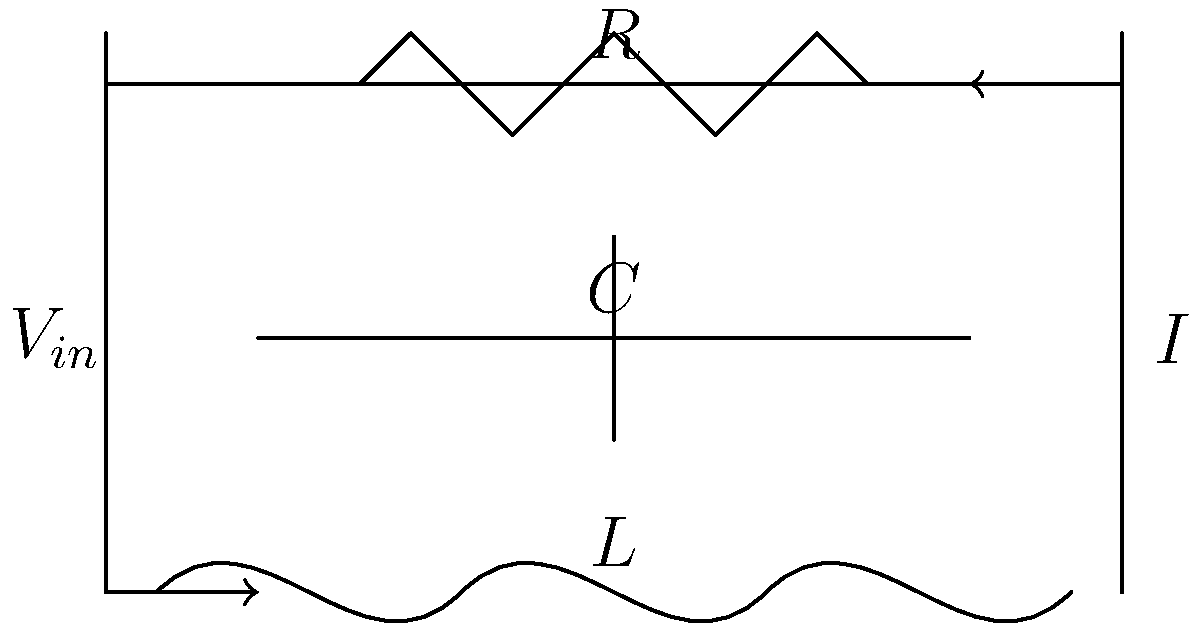In the given circuit diagram representing the electrical activity of gut smooth muscle cells, what is the impedance $Z$ of the circuit at angular frequency $\omega$? To find the impedance of the circuit, we need to follow these steps:

1) Identify the components: The circuit consists of a resistor (R), capacitor (C), and inductor (L) connected in parallel.

2) Recall the impedance formulas for each component:
   - Resistor: $Z_R = R$
   - Capacitor: $Z_C = \frac{1}{j\omega C}$
   - Inductor: $Z_L = j\omega L$

3) For components in parallel, we use the reciprocal of the sum of reciprocals:

   $\frac{1}{Z} = \frac{1}{Z_R} + \frac{1}{Z_C} + \frac{1}{Z_L}$

4) Substitute the component impedances:

   $\frac{1}{Z} = \frac{1}{R} + \frac{1}{\frac{1}{j\omega C}} + \frac{1}{j\omega L}$

5) Simplify:

   $\frac{1}{Z} = \frac{1}{R} + j\omega C + \frac{1}{j\omega L}$

6) Find a common denominator:

   $\frac{1}{Z} = \frac{1}{R} + \frac{j\omega C(j\omega L) + 1}{j\omega L} = \frac{1}{R} + \frac{-\omega^2CL + 1}{j\omega L}$

7) The total impedance is the reciprocal of this sum:

   $Z = \frac{1}{\frac{1}{R} + \frac{-\omega^2CL + 1}{j\omega L}}$

This formula represents the total impedance of the circuit at angular frequency $\omega$.
Answer: $Z = \frac{1}{\frac{1}{R} + \frac{-\omega^2CL + 1}{j\omega L}}$ 